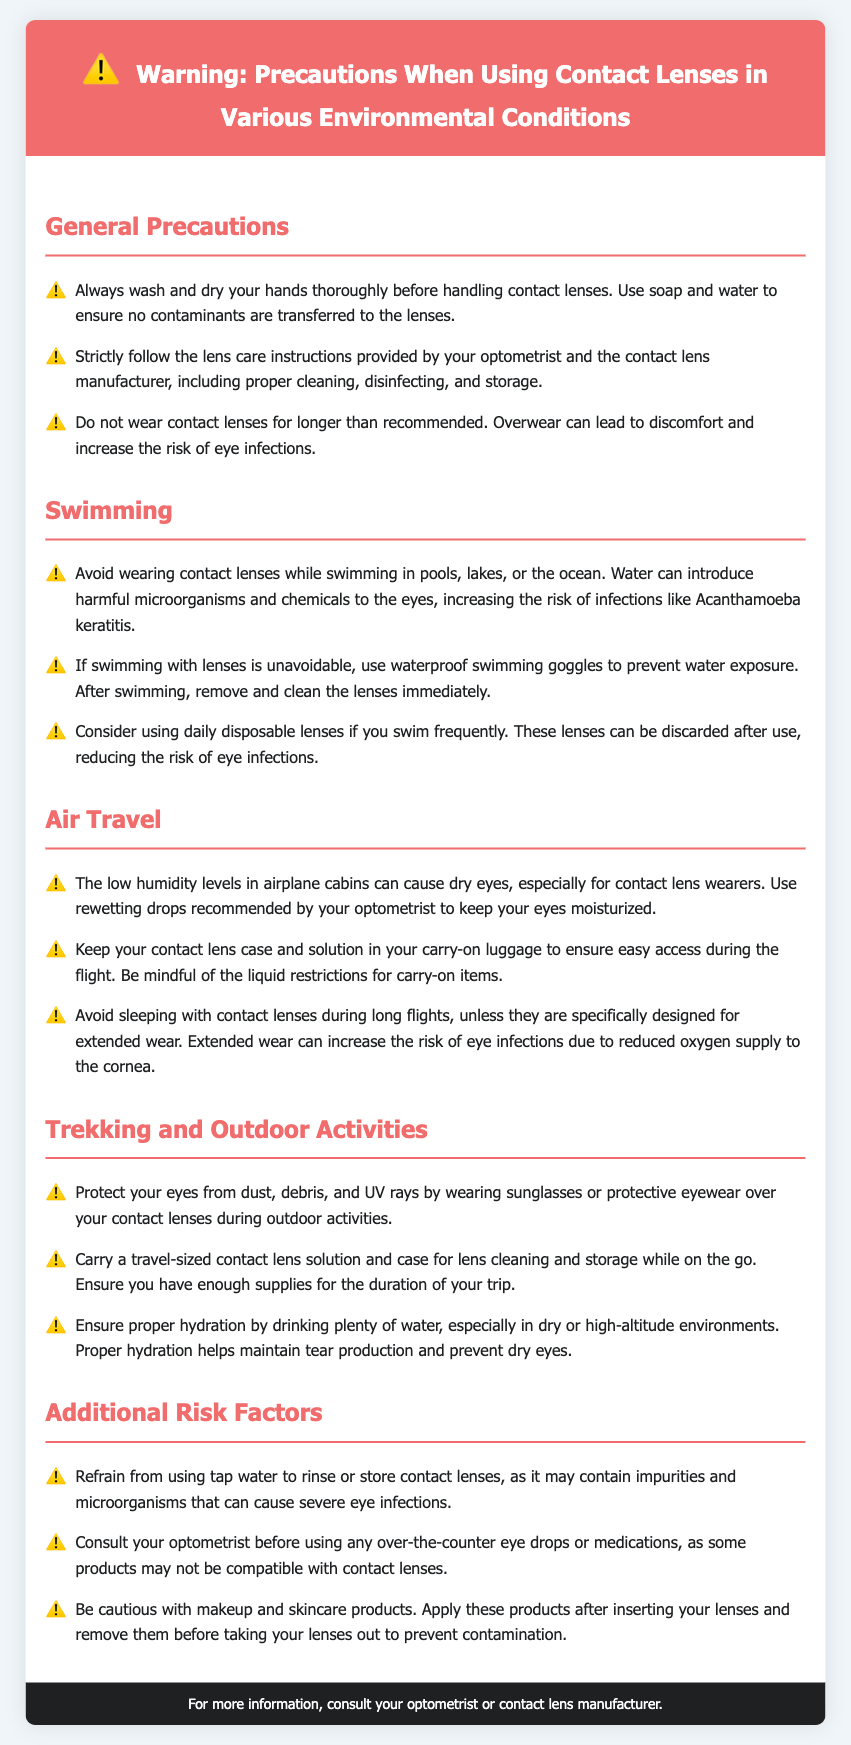What should you do before handling contact lenses? The document advises washing and drying your hands thoroughly before handling contact lenses.
Answer: Wash hands What is a risk of wearing contact lenses while swimming? The document states that wearing contact lenses while swimming increases the risk of infections like Acanthamoeba keratitis.
Answer: Acanthamoeba keratitis What is recommended for keeping eyes moisturized during air travel? The document mentions using rewetting drops recommended by your optometrist to keep eyes moisturized in low humidity.
Answer: Rewetting drops What extra items should you carry while trekking? The document suggests carrying a travel-sized contact lens solution and case for cleaning and storage.
Answer: Travel-sized solution and case What should you avoid using to rinse contact lenses? The document advises against using tap water to rinse or store contact lenses due to impurities.
Answer: Tap water Why should you avoid sleeping with contact lenses during long flights? The document explains that sleeping with contact lenses can increase the risk of eye infections due to reduced oxygen supply to the cornea.
Answer: Risk of eye infections When should you apply makeup in relation to contact lenses? The document states makeup should be applied after inserting lenses and removed before taking them out to avoid contamination.
Answer: After inserting lenses What type of lenses is recommended for frequent swimmers? The document suggests considering daily disposable lenses if swimming frequently to reduce the risk of eye infections.
Answer: Daily disposable lenses 